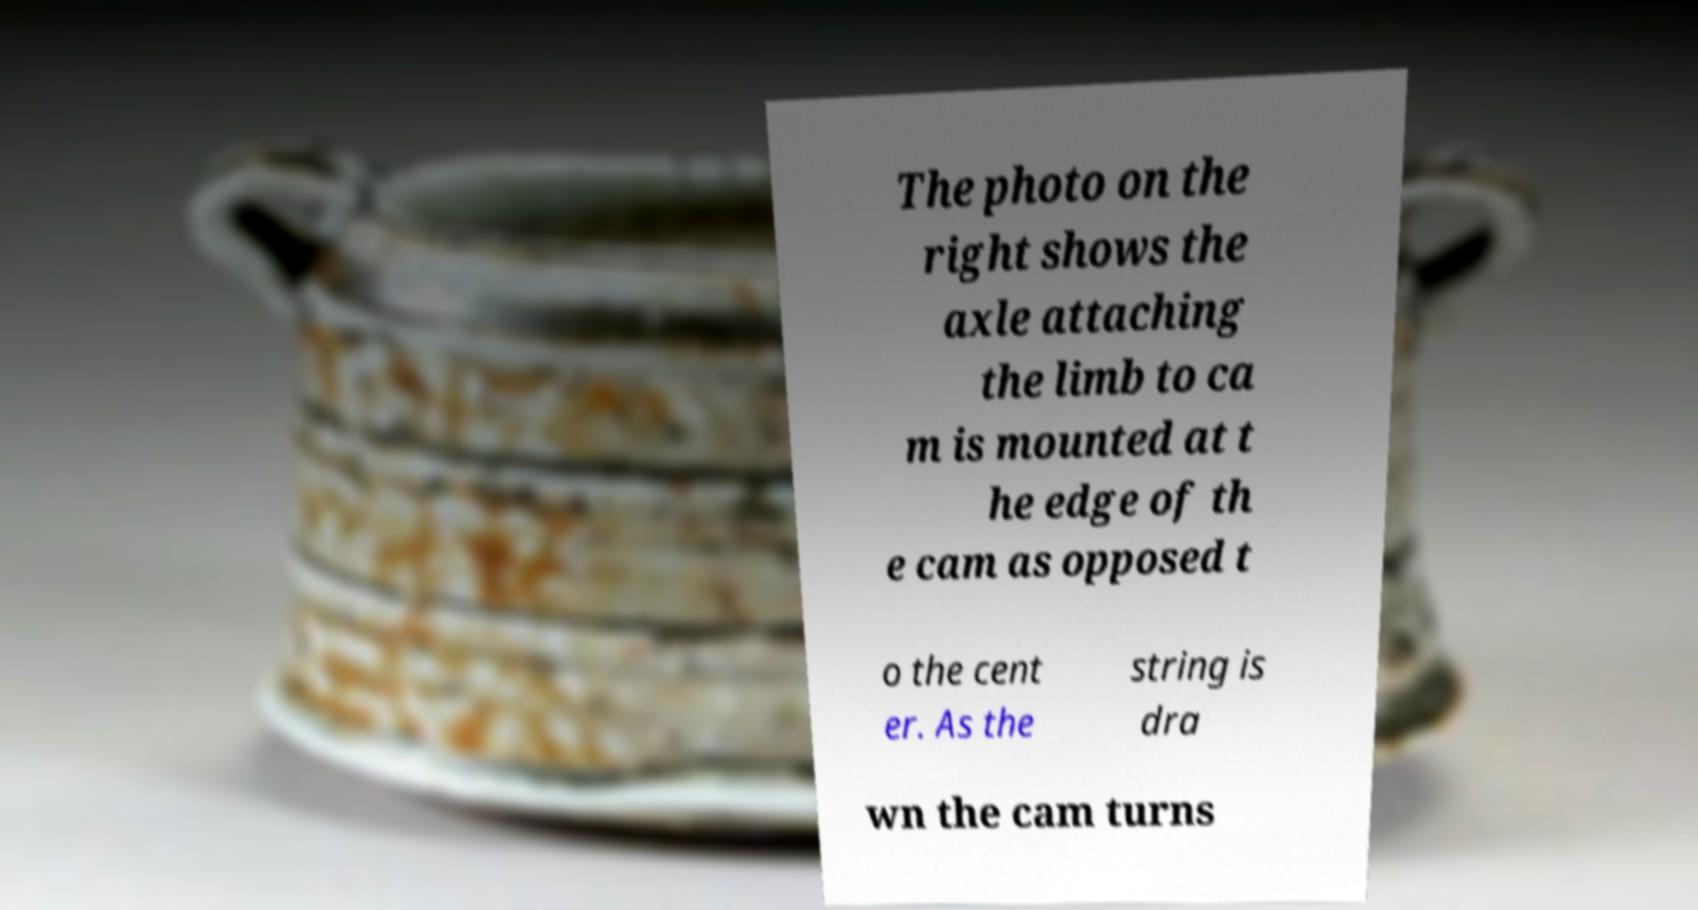There's text embedded in this image that I need extracted. Can you transcribe it verbatim? The photo on the right shows the axle attaching the limb to ca m is mounted at t he edge of th e cam as opposed t o the cent er. As the string is dra wn the cam turns 